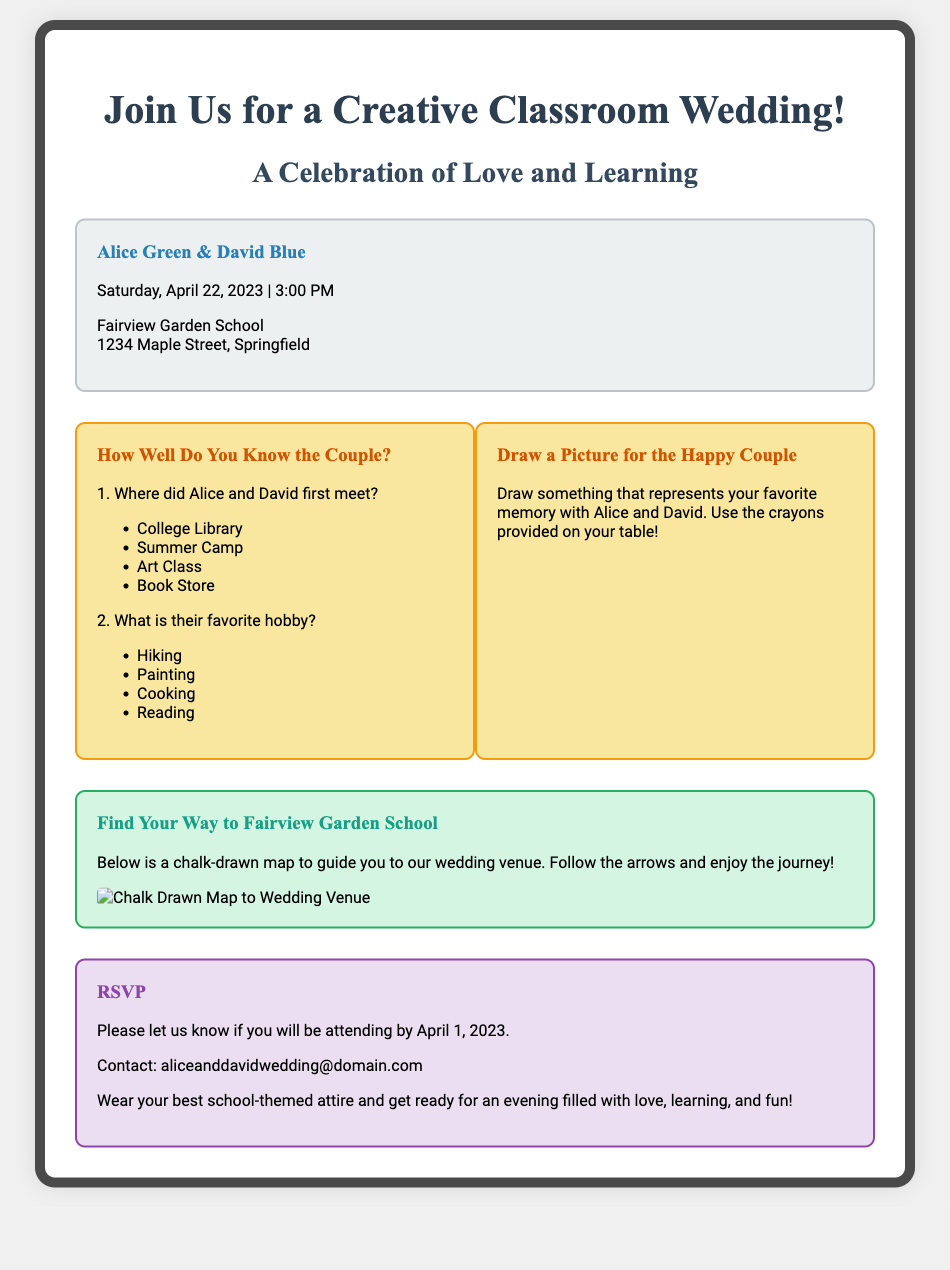What is the theme of the wedding invitation? The wedding invitation emphasizes creativity through elements of a classroom.
Answer: Creative Classroom Wedding Who are the couple getting married? The document provides the names of the couple prominently in the details section.
Answer: Alice Green & David Blue When is the wedding scheduled to take place? The invitation states the date clearly in the details section.
Answer: Saturday, April 22, 2023 Where is the wedding venue located? The invitation specifies the name and address of the venue.
Answer: Fairview Garden School, 1234 Maple Street, Springfield What type of activities are included in the wedding invitation? The invitation mentions interactive elements for guests.
Answer: Mini quizzes and drawing prompts What should guests wear to the wedding? The footer section advises guests on appropriate attire for the event.
Answer: Best school-themed attire What is the RSVP deadline? The invitation mentions a specific date for RSVP responses.
Answer: April 1, 2023 What is the contact information provided for RSVPs? The footer contains a specific contact email for wedding RSVPs.
Answer: aliceanddavidwedding@domain.com What elements are used to create interactivity in the invitation? The document describes engaging features that invite guest participation.
Answer: Mini quizzes and drawing prompts 